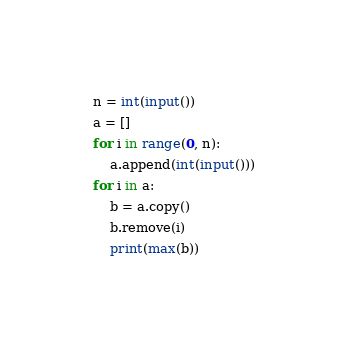<code> <loc_0><loc_0><loc_500><loc_500><_Python_>n = int(input())
a = []
for i in range(0, n):
    a.append(int(input()))
for i in a:
    b = a.copy()
    b.remove(i)
    print(max(b))</code> 